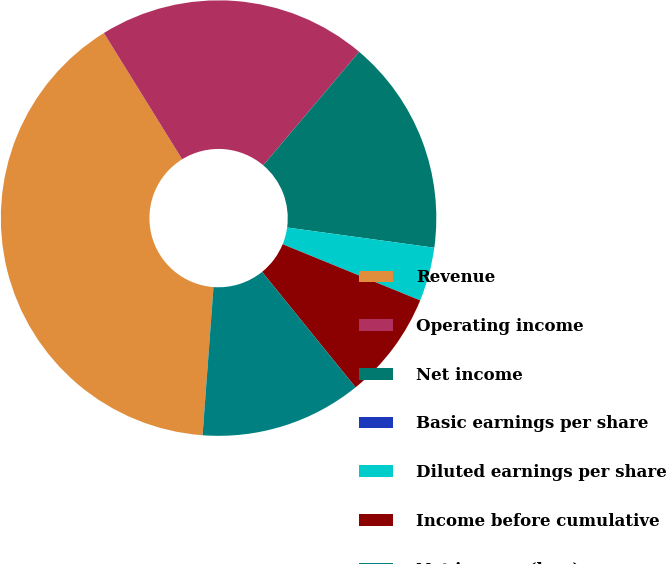Convert chart. <chart><loc_0><loc_0><loc_500><loc_500><pie_chart><fcel>Revenue<fcel>Operating income<fcel>Net income<fcel>Basic earnings per share<fcel>Diluted earnings per share<fcel>Income before cumulative<fcel>Net income (loss)<nl><fcel>40.0%<fcel>20.0%<fcel>16.0%<fcel>0.0%<fcel>4.0%<fcel>8.0%<fcel>12.0%<nl></chart> 